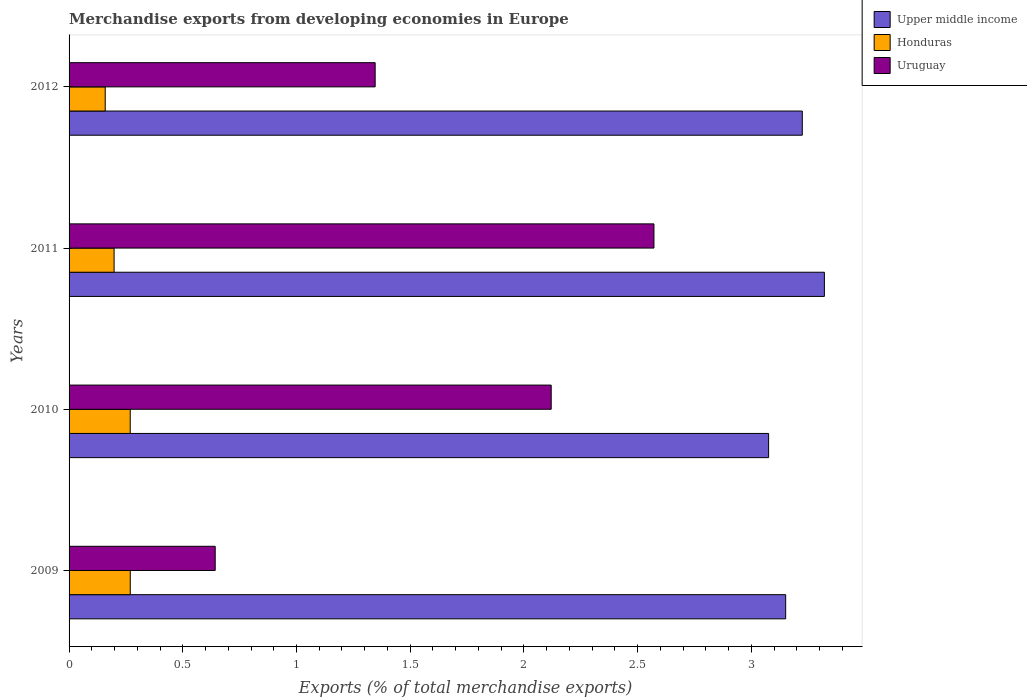How many different coloured bars are there?
Offer a very short reply. 3. How many groups of bars are there?
Make the answer very short. 4. Are the number of bars on each tick of the Y-axis equal?
Your response must be concise. Yes. How many bars are there on the 4th tick from the bottom?
Your response must be concise. 3. In how many cases, is the number of bars for a given year not equal to the number of legend labels?
Give a very brief answer. 0. What is the percentage of total merchandise exports in Upper middle income in 2009?
Give a very brief answer. 3.15. Across all years, what is the maximum percentage of total merchandise exports in Honduras?
Provide a short and direct response. 0.27. Across all years, what is the minimum percentage of total merchandise exports in Honduras?
Your answer should be compact. 0.16. In which year was the percentage of total merchandise exports in Honduras maximum?
Your response must be concise. 2009. In which year was the percentage of total merchandise exports in Uruguay minimum?
Make the answer very short. 2009. What is the total percentage of total merchandise exports in Honduras in the graph?
Provide a succinct answer. 0.89. What is the difference between the percentage of total merchandise exports in Upper middle income in 2010 and that in 2012?
Ensure brevity in your answer.  -0.15. What is the difference between the percentage of total merchandise exports in Upper middle income in 2009 and the percentage of total merchandise exports in Uruguay in 2012?
Ensure brevity in your answer.  1.81. What is the average percentage of total merchandise exports in Upper middle income per year?
Give a very brief answer. 3.19. In the year 2009, what is the difference between the percentage of total merchandise exports in Uruguay and percentage of total merchandise exports in Upper middle income?
Your answer should be very brief. -2.51. In how many years, is the percentage of total merchandise exports in Honduras greater than 1.7 %?
Your response must be concise. 0. What is the ratio of the percentage of total merchandise exports in Honduras in 2009 to that in 2011?
Provide a succinct answer. 1.36. Is the difference between the percentage of total merchandise exports in Uruguay in 2010 and 2012 greater than the difference between the percentage of total merchandise exports in Upper middle income in 2010 and 2012?
Offer a terse response. Yes. What is the difference between the highest and the second highest percentage of total merchandise exports in Upper middle income?
Give a very brief answer. 0.1. What is the difference between the highest and the lowest percentage of total merchandise exports in Upper middle income?
Provide a short and direct response. 0.25. In how many years, is the percentage of total merchandise exports in Upper middle income greater than the average percentage of total merchandise exports in Upper middle income taken over all years?
Your answer should be very brief. 2. What does the 2nd bar from the top in 2010 represents?
Ensure brevity in your answer.  Honduras. What does the 3rd bar from the bottom in 2009 represents?
Your answer should be compact. Uruguay. What is the difference between two consecutive major ticks on the X-axis?
Ensure brevity in your answer.  0.5. Does the graph contain any zero values?
Offer a very short reply. No. Does the graph contain grids?
Your answer should be very brief. No. How are the legend labels stacked?
Your answer should be very brief. Vertical. What is the title of the graph?
Give a very brief answer. Merchandise exports from developing economies in Europe. What is the label or title of the X-axis?
Provide a succinct answer. Exports (% of total merchandise exports). What is the Exports (% of total merchandise exports) of Upper middle income in 2009?
Keep it short and to the point. 3.15. What is the Exports (% of total merchandise exports) in Honduras in 2009?
Your response must be concise. 0.27. What is the Exports (% of total merchandise exports) of Uruguay in 2009?
Ensure brevity in your answer.  0.64. What is the Exports (% of total merchandise exports) of Upper middle income in 2010?
Provide a short and direct response. 3.08. What is the Exports (% of total merchandise exports) of Honduras in 2010?
Ensure brevity in your answer.  0.27. What is the Exports (% of total merchandise exports) in Uruguay in 2010?
Give a very brief answer. 2.12. What is the Exports (% of total merchandise exports) in Upper middle income in 2011?
Your answer should be compact. 3.32. What is the Exports (% of total merchandise exports) in Honduras in 2011?
Give a very brief answer. 0.2. What is the Exports (% of total merchandise exports) of Uruguay in 2011?
Make the answer very short. 2.57. What is the Exports (% of total merchandise exports) of Upper middle income in 2012?
Your response must be concise. 3.22. What is the Exports (% of total merchandise exports) of Honduras in 2012?
Offer a very short reply. 0.16. What is the Exports (% of total merchandise exports) in Uruguay in 2012?
Your response must be concise. 1.35. Across all years, what is the maximum Exports (% of total merchandise exports) of Upper middle income?
Offer a terse response. 3.32. Across all years, what is the maximum Exports (% of total merchandise exports) in Honduras?
Offer a terse response. 0.27. Across all years, what is the maximum Exports (% of total merchandise exports) of Uruguay?
Offer a terse response. 2.57. Across all years, what is the minimum Exports (% of total merchandise exports) in Upper middle income?
Offer a terse response. 3.08. Across all years, what is the minimum Exports (% of total merchandise exports) in Honduras?
Provide a succinct answer. 0.16. Across all years, what is the minimum Exports (% of total merchandise exports) in Uruguay?
Offer a terse response. 0.64. What is the total Exports (% of total merchandise exports) of Upper middle income in the graph?
Give a very brief answer. 12.77. What is the total Exports (% of total merchandise exports) of Honduras in the graph?
Offer a very short reply. 0.9. What is the total Exports (% of total merchandise exports) in Uruguay in the graph?
Your response must be concise. 6.68. What is the difference between the Exports (% of total merchandise exports) in Upper middle income in 2009 and that in 2010?
Ensure brevity in your answer.  0.08. What is the difference between the Exports (% of total merchandise exports) of Uruguay in 2009 and that in 2010?
Ensure brevity in your answer.  -1.48. What is the difference between the Exports (% of total merchandise exports) in Upper middle income in 2009 and that in 2011?
Your answer should be very brief. -0.17. What is the difference between the Exports (% of total merchandise exports) of Honduras in 2009 and that in 2011?
Keep it short and to the point. 0.07. What is the difference between the Exports (% of total merchandise exports) in Uruguay in 2009 and that in 2011?
Your answer should be very brief. -1.93. What is the difference between the Exports (% of total merchandise exports) in Upper middle income in 2009 and that in 2012?
Provide a short and direct response. -0.07. What is the difference between the Exports (% of total merchandise exports) in Honduras in 2009 and that in 2012?
Your response must be concise. 0.11. What is the difference between the Exports (% of total merchandise exports) in Uruguay in 2009 and that in 2012?
Make the answer very short. -0.7. What is the difference between the Exports (% of total merchandise exports) in Upper middle income in 2010 and that in 2011?
Keep it short and to the point. -0.25. What is the difference between the Exports (% of total merchandise exports) of Honduras in 2010 and that in 2011?
Offer a very short reply. 0.07. What is the difference between the Exports (% of total merchandise exports) in Uruguay in 2010 and that in 2011?
Offer a terse response. -0.45. What is the difference between the Exports (% of total merchandise exports) of Upper middle income in 2010 and that in 2012?
Provide a succinct answer. -0.15. What is the difference between the Exports (% of total merchandise exports) in Honduras in 2010 and that in 2012?
Offer a very short reply. 0.11. What is the difference between the Exports (% of total merchandise exports) of Uruguay in 2010 and that in 2012?
Give a very brief answer. 0.77. What is the difference between the Exports (% of total merchandise exports) of Upper middle income in 2011 and that in 2012?
Offer a terse response. 0.1. What is the difference between the Exports (% of total merchandise exports) in Honduras in 2011 and that in 2012?
Provide a short and direct response. 0.04. What is the difference between the Exports (% of total merchandise exports) in Uruguay in 2011 and that in 2012?
Offer a terse response. 1.23. What is the difference between the Exports (% of total merchandise exports) of Upper middle income in 2009 and the Exports (% of total merchandise exports) of Honduras in 2010?
Your response must be concise. 2.88. What is the difference between the Exports (% of total merchandise exports) of Upper middle income in 2009 and the Exports (% of total merchandise exports) of Uruguay in 2010?
Make the answer very short. 1.03. What is the difference between the Exports (% of total merchandise exports) in Honduras in 2009 and the Exports (% of total merchandise exports) in Uruguay in 2010?
Your answer should be compact. -1.85. What is the difference between the Exports (% of total merchandise exports) of Upper middle income in 2009 and the Exports (% of total merchandise exports) of Honduras in 2011?
Keep it short and to the point. 2.95. What is the difference between the Exports (% of total merchandise exports) in Upper middle income in 2009 and the Exports (% of total merchandise exports) in Uruguay in 2011?
Ensure brevity in your answer.  0.58. What is the difference between the Exports (% of total merchandise exports) in Honduras in 2009 and the Exports (% of total merchandise exports) in Uruguay in 2011?
Ensure brevity in your answer.  -2.3. What is the difference between the Exports (% of total merchandise exports) in Upper middle income in 2009 and the Exports (% of total merchandise exports) in Honduras in 2012?
Your response must be concise. 2.99. What is the difference between the Exports (% of total merchandise exports) in Upper middle income in 2009 and the Exports (% of total merchandise exports) in Uruguay in 2012?
Provide a succinct answer. 1.81. What is the difference between the Exports (% of total merchandise exports) in Honduras in 2009 and the Exports (% of total merchandise exports) in Uruguay in 2012?
Your answer should be very brief. -1.08. What is the difference between the Exports (% of total merchandise exports) in Upper middle income in 2010 and the Exports (% of total merchandise exports) in Honduras in 2011?
Your answer should be compact. 2.88. What is the difference between the Exports (% of total merchandise exports) of Upper middle income in 2010 and the Exports (% of total merchandise exports) of Uruguay in 2011?
Offer a terse response. 0.5. What is the difference between the Exports (% of total merchandise exports) of Honduras in 2010 and the Exports (% of total merchandise exports) of Uruguay in 2011?
Your response must be concise. -2.3. What is the difference between the Exports (% of total merchandise exports) in Upper middle income in 2010 and the Exports (% of total merchandise exports) in Honduras in 2012?
Give a very brief answer. 2.92. What is the difference between the Exports (% of total merchandise exports) in Upper middle income in 2010 and the Exports (% of total merchandise exports) in Uruguay in 2012?
Offer a terse response. 1.73. What is the difference between the Exports (% of total merchandise exports) in Honduras in 2010 and the Exports (% of total merchandise exports) in Uruguay in 2012?
Keep it short and to the point. -1.08. What is the difference between the Exports (% of total merchandise exports) of Upper middle income in 2011 and the Exports (% of total merchandise exports) of Honduras in 2012?
Provide a succinct answer. 3.16. What is the difference between the Exports (% of total merchandise exports) in Upper middle income in 2011 and the Exports (% of total merchandise exports) in Uruguay in 2012?
Give a very brief answer. 1.98. What is the difference between the Exports (% of total merchandise exports) of Honduras in 2011 and the Exports (% of total merchandise exports) of Uruguay in 2012?
Provide a short and direct response. -1.15. What is the average Exports (% of total merchandise exports) of Upper middle income per year?
Your answer should be very brief. 3.19. What is the average Exports (% of total merchandise exports) of Honduras per year?
Keep it short and to the point. 0.22. What is the average Exports (% of total merchandise exports) of Uruguay per year?
Make the answer very short. 1.67. In the year 2009, what is the difference between the Exports (% of total merchandise exports) of Upper middle income and Exports (% of total merchandise exports) of Honduras?
Provide a succinct answer. 2.88. In the year 2009, what is the difference between the Exports (% of total merchandise exports) in Upper middle income and Exports (% of total merchandise exports) in Uruguay?
Provide a succinct answer. 2.51. In the year 2009, what is the difference between the Exports (% of total merchandise exports) of Honduras and Exports (% of total merchandise exports) of Uruguay?
Ensure brevity in your answer.  -0.37. In the year 2010, what is the difference between the Exports (% of total merchandise exports) of Upper middle income and Exports (% of total merchandise exports) of Honduras?
Make the answer very short. 2.81. In the year 2010, what is the difference between the Exports (% of total merchandise exports) in Upper middle income and Exports (% of total merchandise exports) in Uruguay?
Your answer should be compact. 0.96. In the year 2010, what is the difference between the Exports (% of total merchandise exports) in Honduras and Exports (% of total merchandise exports) in Uruguay?
Provide a succinct answer. -1.85. In the year 2011, what is the difference between the Exports (% of total merchandise exports) in Upper middle income and Exports (% of total merchandise exports) in Honduras?
Your response must be concise. 3.12. In the year 2011, what is the difference between the Exports (% of total merchandise exports) of Upper middle income and Exports (% of total merchandise exports) of Uruguay?
Your answer should be very brief. 0.75. In the year 2011, what is the difference between the Exports (% of total merchandise exports) in Honduras and Exports (% of total merchandise exports) in Uruguay?
Give a very brief answer. -2.37. In the year 2012, what is the difference between the Exports (% of total merchandise exports) of Upper middle income and Exports (% of total merchandise exports) of Honduras?
Your response must be concise. 3.06. In the year 2012, what is the difference between the Exports (% of total merchandise exports) in Upper middle income and Exports (% of total merchandise exports) in Uruguay?
Your answer should be very brief. 1.88. In the year 2012, what is the difference between the Exports (% of total merchandise exports) in Honduras and Exports (% of total merchandise exports) in Uruguay?
Give a very brief answer. -1.19. What is the ratio of the Exports (% of total merchandise exports) of Upper middle income in 2009 to that in 2010?
Your response must be concise. 1.02. What is the ratio of the Exports (% of total merchandise exports) of Uruguay in 2009 to that in 2010?
Your answer should be compact. 0.3. What is the ratio of the Exports (% of total merchandise exports) of Upper middle income in 2009 to that in 2011?
Ensure brevity in your answer.  0.95. What is the ratio of the Exports (% of total merchandise exports) of Honduras in 2009 to that in 2011?
Give a very brief answer. 1.36. What is the ratio of the Exports (% of total merchandise exports) in Uruguay in 2009 to that in 2011?
Offer a very short reply. 0.25. What is the ratio of the Exports (% of total merchandise exports) in Upper middle income in 2009 to that in 2012?
Offer a very short reply. 0.98. What is the ratio of the Exports (% of total merchandise exports) of Honduras in 2009 to that in 2012?
Your response must be concise. 1.69. What is the ratio of the Exports (% of total merchandise exports) of Uruguay in 2009 to that in 2012?
Provide a short and direct response. 0.48. What is the ratio of the Exports (% of total merchandise exports) of Upper middle income in 2010 to that in 2011?
Ensure brevity in your answer.  0.93. What is the ratio of the Exports (% of total merchandise exports) of Honduras in 2010 to that in 2011?
Your answer should be very brief. 1.36. What is the ratio of the Exports (% of total merchandise exports) in Uruguay in 2010 to that in 2011?
Keep it short and to the point. 0.82. What is the ratio of the Exports (% of total merchandise exports) of Upper middle income in 2010 to that in 2012?
Your response must be concise. 0.95. What is the ratio of the Exports (% of total merchandise exports) of Honduras in 2010 to that in 2012?
Make the answer very short. 1.69. What is the ratio of the Exports (% of total merchandise exports) of Uruguay in 2010 to that in 2012?
Ensure brevity in your answer.  1.58. What is the ratio of the Exports (% of total merchandise exports) in Upper middle income in 2011 to that in 2012?
Provide a short and direct response. 1.03. What is the ratio of the Exports (% of total merchandise exports) in Honduras in 2011 to that in 2012?
Offer a terse response. 1.25. What is the ratio of the Exports (% of total merchandise exports) of Uruguay in 2011 to that in 2012?
Offer a terse response. 1.91. What is the difference between the highest and the second highest Exports (% of total merchandise exports) of Upper middle income?
Make the answer very short. 0.1. What is the difference between the highest and the second highest Exports (% of total merchandise exports) in Honduras?
Offer a terse response. 0. What is the difference between the highest and the second highest Exports (% of total merchandise exports) in Uruguay?
Give a very brief answer. 0.45. What is the difference between the highest and the lowest Exports (% of total merchandise exports) in Upper middle income?
Offer a terse response. 0.25. What is the difference between the highest and the lowest Exports (% of total merchandise exports) in Honduras?
Your response must be concise. 0.11. What is the difference between the highest and the lowest Exports (% of total merchandise exports) in Uruguay?
Your answer should be very brief. 1.93. 